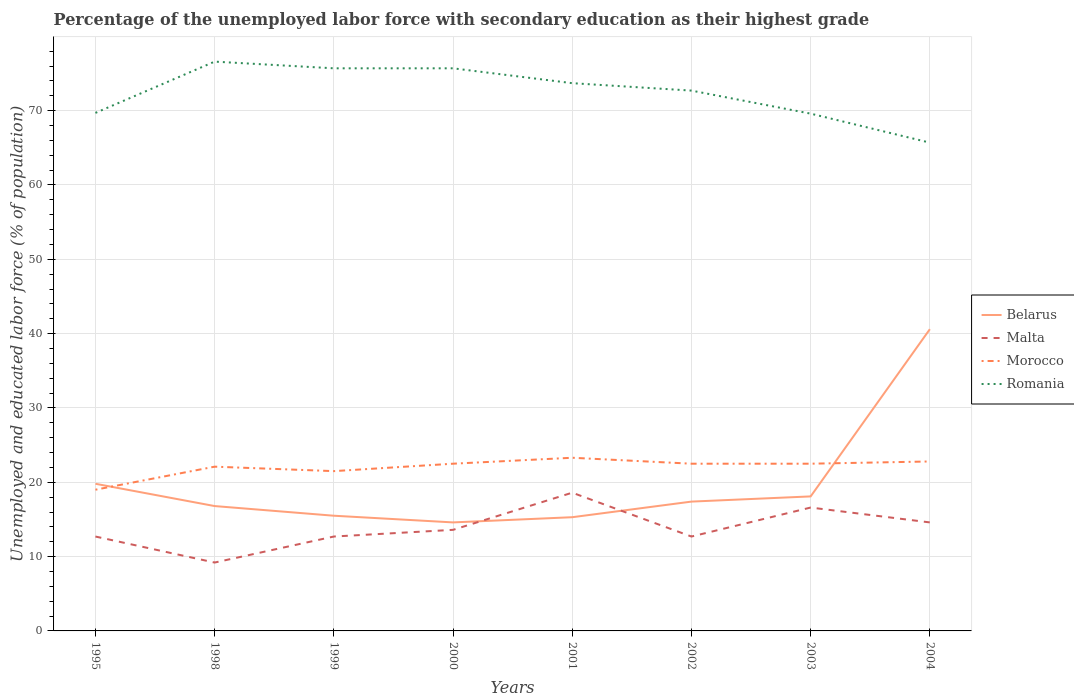Does the line corresponding to Romania intersect with the line corresponding to Morocco?
Your answer should be compact. No. Is the number of lines equal to the number of legend labels?
Your answer should be very brief. Yes. Across all years, what is the maximum percentage of the unemployed labor force with secondary education in Morocco?
Keep it short and to the point. 19. In which year was the percentage of the unemployed labor force with secondary education in Morocco maximum?
Provide a succinct answer. 1995. What is the total percentage of the unemployed labor force with secondary education in Romania in the graph?
Offer a terse response. 3.9. What is the difference between the highest and the second highest percentage of the unemployed labor force with secondary education in Malta?
Ensure brevity in your answer.  9.4. How many lines are there?
Your answer should be very brief. 4. How many years are there in the graph?
Offer a terse response. 8. What is the difference between two consecutive major ticks on the Y-axis?
Your answer should be compact. 10. What is the title of the graph?
Provide a short and direct response. Percentage of the unemployed labor force with secondary education as their highest grade. Does "Slovak Republic" appear as one of the legend labels in the graph?
Ensure brevity in your answer.  No. What is the label or title of the X-axis?
Make the answer very short. Years. What is the label or title of the Y-axis?
Make the answer very short. Unemployed and educated labor force (% of population). What is the Unemployed and educated labor force (% of population) of Belarus in 1995?
Your response must be concise. 19.8. What is the Unemployed and educated labor force (% of population) of Malta in 1995?
Give a very brief answer. 12.7. What is the Unemployed and educated labor force (% of population) in Romania in 1995?
Offer a very short reply. 69.7. What is the Unemployed and educated labor force (% of population) in Belarus in 1998?
Ensure brevity in your answer.  16.8. What is the Unemployed and educated labor force (% of population) of Malta in 1998?
Your answer should be compact. 9.2. What is the Unemployed and educated labor force (% of population) in Morocco in 1998?
Make the answer very short. 22.1. What is the Unemployed and educated labor force (% of population) of Romania in 1998?
Your answer should be very brief. 76.6. What is the Unemployed and educated labor force (% of population) in Malta in 1999?
Your answer should be very brief. 12.7. What is the Unemployed and educated labor force (% of population) in Morocco in 1999?
Your answer should be compact. 21.5. What is the Unemployed and educated labor force (% of population) of Romania in 1999?
Give a very brief answer. 75.7. What is the Unemployed and educated labor force (% of population) of Belarus in 2000?
Your answer should be very brief. 14.6. What is the Unemployed and educated labor force (% of population) of Malta in 2000?
Provide a short and direct response. 13.6. What is the Unemployed and educated labor force (% of population) in Romania in 2000?
Give a very brief answer. 75.7. What is the Unemployed and educated labor force (% of population) of Belarus in 2001?
Offer a very short reply. 15.3. What is the Unemployed and educated labor force (% of population) in Malta in 2001?
Offer a terse response. 18.6. What is the Unemployed and educated labor force (% of population) of Morocco in 2001?
Give a very brief answer. 23.3. What is the Unemployed and educated labor force (% of population) in Romania in 2001?
Your answer should be very brief. 73.7. What is the Unemployed and educated labor force (% of population) in Belarus in 2002?
Provide a short and direct response. 17.4. What is the Unemployed and educated labor force (% of population) of Malta in 2002?
Your response must be concise. 12.7. What is the Unemployed and educated labor force (% of population) in Romania in 2002?
Offer a very short reply. 72.7. What is the Unemployed and educated labor force (% of population) in Belarus in 2003?
Offer a very short reply. 18.1. What is the Unemployed and educated labor force (% of population) in Malta in 2003?
Provide a short and direct response. 16.6. What is the Unemployed and educated labor force (% of population) in Morocco in 2003?
Provide a succinct answer. 22.5. What is the Unemployed and educated labor force (% of population) in Romania in 2003?
Your answer should be compact. 69.6. What is the Unemployed and educated labor force (% of population) of Belarus in 2004?
Make the answer very short. 40.6. What is the Unemployed and educated labor force (% of population) in Malta in 2004?
Provide a succinct answer. 14.6. What is the Unemployed and educated labor force (% of population) in Morocco in 2004?
Your answer should be compact. 22.8. What is the Unemployed and educated labor force (% of population) in Romania in 2004?
Offer a terse response. 65.7. Across all years, what is the maximum Unemployed and educated labor force (% of population) in Belarus?
Give a very brief answer. 40.6. Across all years, what is the maximum Unemployed and educated labor force (% of population) of Malta?
Give a very brief answer. 18.6. Across all years, what is the maximum Unemployed and educated labor force (% of population) of Morocco?
Your answer should be compact. 23.3. Across all years, what is the maximum Unemployed and educated labor force (% of population) of Romania?
Ensure brevity in your answer.  76.6. Across all years, what is the minimum Unemployed and educated labor force (% of population) of Belarus?
Provide a short and direct response. 14.6. Across all years, what is the minimum Unemployed and educated labor force (% of population) in Malta?
Give a very brief answer. 9.2. Across all years, what is the minimum Unemployed and educated labor force (% of population) in Romania?
Provide a short and direct response. 65.7. What is the total Unemployed and educated labor force (% of population) in Belarus in the graph?
Your answer should be very brief. 158.1. What is the total Unemployed and educated labor force (% of population) in Malta in the graph?
Your response must be concise. 110.7. What is the total Unemployed and educated labor force (% of population) in Morocco in the graph?
Your response must be concise. 176.2. What is the total Unemployed and educated labor force (% of population) of Romania in the graph?
Give a very brief answer. 579.4. What is the difference between the Unemployed and educated labor force (% of population) in Belarus in 1995 and that in 1998?
Your response must be concise. 3. What is the difference between the Unemployed and educated labor force (% of population) in Malta in 1995 and that in 1998?
Your response must be concise. 3.5. What is the difference between the Unemployed and educated labor force (% of population) of Morocco in 1995 and that in 1998?
Keep it short and to the point. -3.1. What is the difference between the Unemployed and educated labor force (% of population) of Romania in 1995 and that in 1998?
Give a very brief answer. -6.9. What is the difference between the Unemployed and educated labor force (% of population) of Morocco in 1995 and that in 1999?
Offer a very short reply. -2.5. What is the difference between the Unemployed and educated labor force (% of population) in Romania in 1995 and that in 1999?
Provide a succinct answer. -6. What is the difference between the Unemployed and educated labor force (% of population) of Malta in 1995 and that in 2000?
Provide a succinct answer. -0.9. What is the difference between the Unemployed and educated labor force (% of population) in Belarus in 1995 and that in 2001?
Your response must be concise. 4.5. What is the difference between the Unemployed and educated labor force (% of population) in Malta in 1995 and that in 2001?
Your answer should be compact. -5.9. What is the difference between the Unemployed and educated labor force (% of population) in Romania in 1995 and that in 2001?
Offer a terse response. -4. What is the difference between the Unemployed and educated labor force (% of population) of Belarus in 1995 and that in 2002?
Keep it short and to the point. 2.4. What is the difference between the Unemployed and educated labor force (% of population) in Morocco in 1995 and that in 2002?
Ensure brevity in your answer.  -3.5. What is the difference between the Unemployed and educated labor force (% of population) of Belarus in 1995 and that in 2003?
Ensure brevity in your answer.  1.7. What is the difference between the Unemployed and educated labor force (% of population) in Romania in 1995 and that in 2003?
Your answer should be very brief. 0.1. What is the difference between the Unemployed and educated labor force (% of population) of Belarus in 1995 and that in 2004?
Your response must be concise. -20.8. What is the difference between the Unemployed and educated labor force (% of population) in Morocco in 1995 and that in 2004?
Keep it short and to the point. -3.8. What is the difference between the Unemployed and educated labor force (% of population) of Romania in 1995 and that in 2004?
Your answer should be very brief. 4. What is the difference between the Unemployed and educated labor force (% of population) of Belarus in 1998 and that in 1999?
Give a very brief answer. 1.3. What is the difference between the Unemployed and educated labor force (% of population) in Morocco in 1998 and that in 1999?
Your answer should be very brief. 0.6. What is the difference between the Unemployed and educated labor force (% of population) of Romania in 1998 and that in 2000?
Provide a short and direct response. 0.9. What is the difference between the Unemployed and educated labor force (% of population) in Belarus in 1998 and that in 2001?
Provide a short and direct response. 1.5. What is the difference between the Unemployed and educated labor force (% of population) in Belarus in 1998 and that in 2002?
Provide a succinct answer. -0.6. What is the difference between the Unemployed and educated labor force (% of population) of Malta in 1998 and that in 2002?
Keep it short and to the point. -3.5. What is the difference between the Unemployed and educated labor force (% of population) in Morocco in 1998 and that in 2002?
Ensure brevity in your answer.  -0.4. What is the difference between the Unemployed and educated labor force (% of population) of Romania in 1998 and that in 2002?
Your answer should be very brief. 3.9. What is the difference between the Unemployed and educated labor force (% of population) in Belarus in 1998 and that in 2003?
Offer a very short reply. -1.3. What is the difference between the Unemployed and educated labor force (% of population) in Morocco in 1998 and that in 2003?
Offer a very short reply. -0.4. What is the difference between the Unemployed and educated labor force (% of population) of Belarus in 1998 and that in 2004?
Your response must be concise. -23.8. What is the difference between the Unemployed and educated labor force (% of population) in Belarus in 1999 and that in 2000?
Give a very brief answer. 0.9. What is the difference between the Unemployed and educated labor force (% of population) in Romania in 1999 and that in 2001?
Provide a short and direct response. 2. What is the difference between the Unemployed and educated labor force (% of population) of Morocco in 1999 and that in 2002?
Give a very brief answer. -1. What is the difference between the Unemployed and educated labor force (% of population) in Romania in 1999 and that in 2002?
Your response must be concise. 3. What is the difference between the Unemployed and educated labor force (% of population) of Belarus in 1999 and that in 2003?
Provide a short and direct response. -2.6. What is the difference between the Unemployed and educated labor force (% of population) of Belarus in 1999 and that in 2004?
Make the answer very short. -25.1. What is the difference between the Unemployed and educated labor force (% of population) in Malta in 1999 and that in 2004?
Your answer should be very brief. -1.9. What is the difference between the Unemployed and educated labor force (% of population) of Morocco in 1999 and that in 2004?
Make the answer very short. -1.3. What is the difference between the Unemployed and educated labor force (% of population) of Belarus in 2000 and that in 2001?
Make the answer very short. -0.7. What is the difference between the Unemployed and educated labor force (% of population) in Malta in 2000 and that in 2001?
Give a very brief answer. -5. What is the difference between the Unemployed and educated labor force (% of population) of Morocco in 2000 and that in 2002?
Offer a terse response. 0. What is the difference between the Unemployed and educated labor force (% of population) of Malta in 2000 and that in 2003?
Provide a short and direct response. -3. What is the difference between the Unemployed and educated labor force (% of population) of Romania in 2000 and that in 2003?
Provide a succinct answer. 6.1. What is the difference between the Unemployed and educated labor force (% of population) in Belarus in 2001 and that in 2002?
Provide a succinct answer. -2.1. What is the difference between the Unemployed and educated labor force (% of population) in Malta in 2001 and that in 2002?
Provide a succinct answer. 5.9. What is the difference between the Unemployed and educated labor force (% of population) in Morocco in 2001 and that in 2002?
Make the answer very short. 0.8. What is the difference between the Unemployed and educated labor force (% of population) in Romania in 2001 and that in 2002?
Provide a succinct answer. 1. What is the difference between the Unemployed and educated labor force (% of population) in Belarus in 2001 and that in 2003?
Offer a terse response. -2.8. What is the difference between the Unemployed and educated labor force (% of population) of Morocco in 2001 and that in 2003?
Make the answer very short. 0.8. What is the difference between the Unemployed and educated labor force (% of population) in Romania in 2001 and that in 2003?
Ensure brevity in your answer.  4.1. What is the difference between the Unemployed and educated labor force (% of population) in Belarus in 2001 and that in 2004?
Give a very brief answer. -25.3. What is the difference between the Unemployed and educated labor force (% of population) in Morocco in 2001 and that in 2004?
Provide a succinct answer. 0.5. What is the difference between the Unemployed and educated labor force (% of population) of Malta in 2002 and that in 2003?
Keep it short and to the point. -3.9. What is the difference between the Unemployed and educated labor force (% of population) of Morocco in 2002 and that in 2003?
Your answer should be very brief. 0. What is the difference between the Unemployed and educated labor force (% of population) of Romania in 2002 and that in 2003?
Keep it short and to the point. 3.1. What is the difference between the Unemployed and educated labor force (% of population) in Belarus in 2002 and that in 2004?
Provide a succinct answer. -23.2. What is the difference between the Unemployed and educated labor force (% of population) in Malta in 2002 and that in 2004?
Make the answer very short. -1.9. What is the difference between the Unemployed and educated labor force (% of population) of Romania in 2002 and that in 2004?
Ensure brevity in your answer.  7. What is the difference between the Unemployed and educated labor force (% of population) of Belarus in 2003 and that in 2004?
Your answer should be compact. -22.5. What is the difference between the Unemployed and educated labor force (% of population) of Malta in 2003 and that in 2004?
Keep it short and to the point. 2. What is the difference between the Unemployed and educated labor force (% of population) of Morocco in 2003 and that in 2004?
Your answer should be compact. -0.3. What is the difference between the Unemployed and educated labor force (% of population) of Romania in 2003 and that in 2004?
Give a very brief answer. 3.9. What is the difference between the Unemployed and educated labor force (% of population) of Belarus in 1995 and the Unemployed and educated labor force (% of population) of Romania in 1998?
Provide a succinct answer. -56.8. What is the difference between the Unemployed and educated labor force (% of population) of Malta in 1995 and the Unemployed and educated labor force (% of population) of Morocco in 1998?
Give a very brief answer. -9.4. What is the difference between the Unemployed and educated labor force (% of population) of Malta in 1995 and the Unemployed and educated labor force (% of population) of Romania in 1998?
Keep it short and to the point. -63.9. What is the difference between the Unemployed and educated labor force (% of population) in Morocco in 1995 and the Unemployed and educated labor force (% of population) in Romania in 1998?
Keep it short and to the point. -57.6. What is the difference between the Unemployed and educated labor force (% of population) in Belarus in 1995 and the Unemployed and educated labor force (% of population) in Malta in 1999?
Keep it short and to the point. 7.1. What is the difference between the Unemployed and educated labor force (% of population) of Belarus in 1995 and the Unemployed and educated labor force (% of population) of Morocco in 1999?
Your answer should be compact. -1.7. What is the difference between the Unemployed and educated labor force (% of population) of Belarus in 1995 and the Unemployed and educated labor force (% of population) of Romania in 1999?
Keep it short and to the point. -55.9. What is the difference between the Unemployed and educated labor force (% of population) of Malta in 1995 and the Unemployed and educated labor force (% of population) of Morocco in 1999?
Your response must be concise. -8.8. What is the difference between the Unemployed and educated labor force (% of population) of Malta in 1995 and the Unemployed and educated labor force (% of population) of Romania in 1999?
Make the answer very short. -63. What is the difference between the Unemployed and educated labor force (% of population) of Morocco in 1995 and the Unemployed and educated labor force (% of population) of Romania in 1999?
Your answer should be compact. -56.7. What is the difference between the Unemployed and educated labor force (% of population) in Belarus in 1995 and the Unemployed and educated labor force (% of population) in Romania in 2000?
Ensure brevity in your answer.  -55.9. What is the difference between the Unemployed and educated labor force (% of population) of Malta in 1995 and the Unemployed and educated labor force (% of population) of Romania in 2000?
Offer a very short reply. -63. What is the difference between the Unemployed and educated labor force (% of population) of Morocco in 1995 and the Unemployed and educated labor force (% of population) of Romania in 2000?
Ensure brevity in your answer.  -56.7. What is the difference between the Unemployed and educated labor force (% of population) in Belarus in 1995 and the Unemployed and educated labor force (% of population) in Malta in 2001?
Offer a very short reply. 1.2. What is the difference between the Unemployed and educated labor force (% of population) of Belarus in 1995 and the Unemployed and educated labor force (% of population) of Romania in 2001?
Ensure brevity in your answer.  -53.9. What is the difference between the Unemployed and educated labor force (% of population) of Malta in 1995 and the Unemployed and educated labor force (% of population) of Romania in 2001?
Keep it short and to the point. -61. What is the difference between the Unemployed and educated labor force (% of population) in Morocco in 1995 and the Unemployed and educated labor force (% of population) in Romania in 2001?
Offer a very short reply. -54.7. What is the difference between the Unemployed and educated labor force (% of population) in Belarus in 1995 and the Unemployed and educated labor force (% of population) in Morocco in 2002?
Your answer should be compact. -2.7. What is the difference between the Unemployed and educated labor force (% of population) of Belarus in 1995 and the Unemployed and educated labor force (% of population) of Romania in 2002?
Ensure brevity in your answer.  -52.9. What is the difference between the Unemployed and educated labor force (% of population) in Malta in 1995 and the Unemployed and educated labor force (% of population) in Romania in 2002?
Your response must be concise. -60. What is the difference between the Unemployed and educated labor force (% of population) of Morocco in 1995 and the Unemployed and educated labor force (% of population) of Romania in 2002?
Give a very brief answer. -53.7. What is the difference between the Unemployed and educated labor force (% of population) in Belarus in 1995 and the Unemployed and educated labor force (% of population) in Malta in 2003?
Keep it short and to the point. 3.2. What is the difference between the Unemployed and educated labor force (% of population) of Belarus in 1995 and the Unemployed and educated labor force (% of population) of Romania in 2003?
Give a very brief answer. -49.8. What is the difference between the Unemployed and educated labor force (% of population) of Malta in 1995 and the Unemployed and educated labor force (% of population) of Morocco in 2003?
Keep it short and to the point. -9.8. What is the difference between the Unemployed and educated labor force (% of population) of Malta in 1995 and the Unemployed and educated labor force (% of population) of Romania in 2003?
Your answer should be very brief. -56.9. What is the difference between the Unemployed and educated labor force (% of population) of Morocco in 1995 and the Unemployed and educated labor force (% of population) of Romania in 2003?
Ensure brevity in your answer.  -50.6. What is the difference between the Unemployed and educated labor force (% of population) in Belarus in 1995 and the Unemployed and educated labor force (% of population) in Morocco in 2004?
Offer a very short reply. -3. What is the difference between the Unemployed and educated labor force (% of population) of Belarus in 1995 and the Unemployed and educated labor force (% of population) of Romania in 2004?
Offer a very short reply. -45.9. What is the difference between the Unemployed and educated labor force (% of population) of Malta in 1995 and the Unemployed and educated labor force (% of population) of Romania in 2004?
Give a very brief answer. -53. What is the difference between the Unemployed and educated labor force (% of population) in Morocco in 1995 and the Unemployed and educated labor force (% of population) in Romania in 2004?
Keep it short and to the point. -46.7. What is the difference between the Unemployed and educated labor force (% of population) of Belarus in 1998 and the Unemployed and educated labor force (% of population) of Malta in 1999?
Your answer should be compact. 4.1. What is the difference between the Unemployed and educated labor force (% of population) of Belarus in 1998 and the Unemployed and educated labor force (% of population) of Morocco in 1999?
Make the answer very short. -4.7. What is the difference between the Unemployed and educated labor force (% of population) of Belarus in 1998 and the Unemployed and educated labor force (% of population) of Romania in 1999?
Keep it short and to the point. -58.9. What is the difference between the Unemployed and educated labor force (% of population) of Malta in 1998 and the Unemployed and educated labor force (% of population) of Romania in 1999?
Your response must be concise. -66.5. What is the difference between the Unemployed and educated labor force (% of population) in Morocco in 1998 and the Unemployed and educated labor force (% of population) in Romania in 1999?
Provide a short and direct response. -53.6. What is the difference between the Unemployed and educated labor force (% of population) in Belarus in 1998 and the Unemployed and educated labor force (% of population) in Malta in 2000?
Your response must be concise. 3.2. What is the difference between the Unemployed and educated labor force (% of population) in Belarus in 1998 and the Unemployed and educated labor force (% of population) in Romania in 2000?
Keep it short and to the point. -58.9. What is the difference between the Unemployed and educated labor force (% of population) of Malta in 1998 and the Unemployed and educated labor force (% of population) of Morocco in 2000?
Give a very brief answer. -13.3. What is the difference between the Unemployed and educated labor force (% of population) of Malta in 1998 and the Unemployed and educated labor force (% of population) of Romania in 2000?
Ensure brevity in your answer.  -66.5. What is the difference between the Unemployed and educated labor force (% of population) in Morocco in 1998 and the Unemployed and educated labor force (% of population) in Romania in 2000?
Ensure brevity in your answer.  -53.6. What is the difference between the Unemployed and educated labor force (% of population) of Belarus in 1998 and the Unemployed and educated labor force (% of population) of Romania in 2001?
Provide a succinct answer. -56.9. What is the difference between the Unemployed and educated labor force (% of population) in Malta in 1998 and the Unemployed and educated labor force (% of population) in Morocco in 2001?
Keep it short and to the point. -14.1. What is the difference between the Unemployed and educated labor force (% of population) of Malta in 1998 and the Unemployed and educated labor force (% of population) of Romania in 2001?
Your answer should be compact. -64.5. What is the difference between the Unemployed and educated labor force (% of population) of Morocco in 1998 and the Unemployed and educated labor force (% of population) of Romania in 2001?
Make the answer very short. -51.6. What is the difference between the Unemployed and educated labor force (% of population) of Belarus in 1998 and the Unemployed and educated labor force (% of population) of Malta in 2002?
Provide a short and direct response. 4.1. What is the difference between the Unemployed and educated labor force (% of population) of Belarus in 1998 and the Unemployed and educated labor force (% of population) of Morocco in 2002?
Your answer should be very brief. -5.7. What is the difference between the Unemployed and educated labor force (% of population) in Belarus in 1998 and the Unemployed and educated labor force (% of population) in Romania in 2002?
Ensure brevity in your answer.  -55.9. What is the difference between the Unemployed and educated labor force (% of population) in Malta in 1998 and the Unemployed and educated labor force (% of population) in Romania in 2002?
Offer a very short reply. -63.5. What is the difference between the Unemployed and educated labor force (% of population) of Morocco in 1998 and the Unemployed and educated labor force (% of population) of Romania in 2002?
Your answer should be very brief. -50.6. What is the difference between the Unemployed and educated labor force (% of population) in Belarus in 1998 and the Unemployed and educated labor force (% of population) in Morocco in 2003?
Give a very brief answer. -5.7. What is the difference between the Unemployed and educated labor force (% of population) of Belarus in 1998 and the Unemployed and educated labor force (% of population) of Romania in 2003?
Provide a short and direct response. -52.8. What is the difference between the Unemployed and educated labor force (% of population) in Malta in 1998 and the Unemployed and educated labor force (% of population) in Morocco in 2003?
Provide a succinct answer. -13.3. What is the difference between the Unemployed and educated labor force (% of population) of Malta in 1998 and the Unemployed and educated labor force (% of population) of Romania in 2003?
Keep it short and to the point. -60.4. What is the difference between the Unemployed and educated labor force (% of population) in Morocco in 1998 and the Unemployed and educated labor force (% of population) in Romania in 2003?
Provide a succinct answer. -47.5. What is the difference between the Unemployed and educated labor force (% of population) in Belarus in 1998 and the Unemployed and educated labor force (% of population) in Malta in 2004?
Give a very brief answer. 2.2. What is the difference between the Unemployed and educated labor force (% of population) of Belarus in 1998 and the Unemployed and educated labor force (% of population) of Romania in 2004?
Your response must be concise. -48.9. What is the difference between the Unemployed and educated labor force (% of population) in Malta in 1998 and the Unemployed and educated labor force (% of population) in Romania in 2004?
Provide a short and direct response. -56.5. What is the difference between the Unemployed and educated labor force (% of population) in Morocco in 1998 and the Unemployed and educated labor force (% of population) in Romania in 2004?
Give a very brief answer. -43.6. What is the difference between the Unemployed and educated labor force (% of population) in Belarus in 1999 and the Unemployed and educated labor force (% of population) in Morocco in 2000?
Offer a terse response. -7. What is the difference between the Unemployed and educated labor force (% of population) of Belarus in 1999 and the Unemployed and educated labor force (% of population) of Romania in 2000?
Your answer should be very brief. -60.2. What is the difference between the Unemployed and educated labor force (% of population) of Malta in 1999 and the Unemployed and educated labor force (% of population) of Romania in 2000?
Ensure brevity in your answer.  -63. What is the difference between the Unemployed and educated labor force (% of population) of Morocco in 1999 and the Unemployed and educated labor force (% of population) of Romania in 2000?
Offer a very short reply. -54.2. What is the difference between the Unemployed and educated labor force (% of population) in Belarus in 1999 and the Unemployed and educated labor force (% of population) in Malta in 2001?
Your answer should be compact. -3.1. What is the difference between the Unemployed and educated labor force (% of population) in Belarus in 1999 and the Unemployed and educated labor force (% of population) in Romania in 2001?
Provide a succinct answer. -58.2. What is the difference between the Unemployed and educated labor force (% of population) in Malta in 1999 and the Unemployed and educated labor force (% of population) in Morocco in 2001?
Your response must be concise. -10.6. What is the difference between the Unemployed and educated labor force (% of population) of Malta in 1999 and the Unemployed and educated labor force (% of population) of Romania in 2001?
Provide a succinct answer. -61. What is the difference between the Unemployed and educated labor force (% of population) in Morocco in 1999 and the Unemployed and educated labor force (% of population) in Romania in 2001?
Provide a short and direct response. -52.2. What is the difference between the Unemployed and educated labor force (% of population) of Belarus in 1999 and the Unemployed and educated labor force (% of population) of Romania in 2002?
Your answer should be compact. -57.2. What is the difference between the Unemployed and educated labor force (% of population) of Malta in 1999 and the Unemployed and educated labor force (% of population) of Morocco in 2002?
Keep it short and to the point. -9.8. What is the difference between the Unemployed and educated labor force (% of population) in Malta in 1999 and the Unemployed and educated labor force (% of population) in Romania in 2002?
Provide a succinct answer. -60. What is the difference between the Unemployed and educated labor force (% of population) in Morocco in 1999 and the Unemployed and educated labor force (% of population) in Romania in 2002?
Ensure brevity in your answer.  -51.2. What is the difference between the Unemployed and educated labor force (% of population) in Belarus in 1999 and the Unemployed and educated labor force (% of population) in Romania in 2003?
Offer a terse response. -54.1. What is the difference between the Unemployed and educated labor force (% of population) in Malta in 1999 and the Unemployed and educated labor force (% of population) in Morocco in 2003?
Offer a very short reply. -9.8. What is the difference between the Unemployed and educated labor force (% of population) of Malta in 1999 and the Unemployed and educated labor force (% of population) of Romania in 2003?
Offer a terse response. -56.9. What is the difference between the Unemployed and educated labor force (% of population) in Morocco in 1999 and the Unemployed and educated labor force (% of population) in Romania in 2003?
Offer a very short reply. -48.1. What is the difference between the Unemployed and educated labor force (% of population) of Belarus in 1999 and the Unemployed and educated labor force (% of population) of Romania in 2004?
Your answer should be very brief. -50.2. What is the difference between the Unemployed and educated labor force (% of population) of Malta in 1999 and the Unemployed and educated labor force (% of population) of Romania in 2004?
Your response must be concise. -53. What is the difference between the Unemployed and educated labor force (% of population) in Morocco in 1999 and the Unemployed and educated labor force (% of population) in Romania in 2004?
Make the answer very short. -44.2. What is the difference between the Unemployed and educated labor force (% of population) of Belarus in 2000 and the Unemployed and educated labor force (% of population) of Malta in 2001?
Make the answer very short. -4. What is the difference between the Unemployed and educated labor force (% of population) of Belarus in 2000 and the Unemployed and educated labor force (% of population) of Romania in 2001?
Your response must be concise. -59.1. What is the difference between the Unemployed and educated labor force (% of population) of Malta in 2000 and the Unemployed and educated labor force (% of population) of Romania in 2001?
Provide a short and direct response. -60.1. What is the difference between the Unemployed and educated labor force (% of population) in Morocco in 2000 and the Unemployed and educated labor force (% of population) in Romania in 2001?
Keep it short and to the point. -51.2. What is the difference between the Unemployed and educated labor force (% of population) in Belarus in 2000 and the Unemployed and educated labor force (% of population) in Malta in 2002?
Your response must be concise. 1.9. What is the difference between the Unemployed and educated labor force (% of population) of Belarus in 2000 and the Unemployed and educated labor force (% of population) of Morocco in 2002?
Your response must be concise. -7.9. What is the difference between the Unemployed and educated labor force (% of population) of Belarus in 2000 and the Unemployed and educated labor force (% of population) of Romania in 2002?
Offer a very short reply. -58.1. What is the difference between the Unemployed and educated labor force (% of population) of Malta in 2000 and the Unemployed and educated labor force (% of population) of Romania in 2002?
Offer a very short reply. -59.1. What is the difference between the Unemployed and educated labor force (% of population) of Morocco in 2000 and the Unemployed and educated labor force (% of population) of Romania in 2002?
Provide a succinct answer. -50.2. What is the difference between the Unemployed and educated labor force (% of population) in Belarus in 2000 and the Unemployed and educated labor force (% of population) in Malta in 2003?
Ensure brevity in your answer.  -2. What is the difference between the Unemployed and educated labor force (% of population) in Belarus in 2000 and the Unemployed and educated labor force (% of population) in Romania in 2003?
Keep it short and to the point. -55. What is the difference between the Unemployed and educated labor force (% of population) of Malta in 2000 and the Unemployed and educated labor force (% of population) of Morocco in 2003?
Ensure brevity in your answer.  -8.9. What is the difference between the Unemployed and educated labor force (% of population) of Malta in 2000 and the Unemployed and educated labor force (% of population) of Romania in 2003?
Provide a succinct answer. -56. What is the difference between the Unemployed and educated labor force (% of population) of Morocco in 2000 and the Unemployed and educated labor force (% of population) of Romania in 2003?
Offer a terse response. -47.1. What is the difference between the Unemployed and educated labor force (% of population) of Belarus in 2000 and the Unemployed and educated labor force (% of population) of Malta in 2004?
Provide a short and direct response. 0. What is the difference between the Unemployed and educated labor force (% of population) in Belarus in 2000 and the Unemployed and educated labor force (% of population) in Romania in 2004?
Offer a very short reply. -51.1. What is the difference between the Unemployed and educated labor force (% of population) in Malta in 2000 and the Unemployed and educated labor force (% of population) in Morocco in 2004?
Your answer should be compact. -9.2. What is the difference between the Unemployed and educated labor force (% of population) in Malta in 2000 and the Unemployed and educated labor force (% of population) in Romania in 2004?
Provide a short and direct response. -52.1. What is the difference between the Unemployed and educated labor force (% of population) of Morocco in 2000 and the Unemployed and educated labor force (% of population) of Romania in 2004?
Ensure brevity in your answer.  -43.2. What is the difference between the Unemployed and educated labor force (% of population) of Belarus in 2001 and the Unemployed and educated labor force (% of population) of Morocco in 2002?
Your answer should be very brief. -7.2. What is the difference between the Unemployed and educated labor force (% of population) in Belarus in 2001 and the Unemployed and educated labor force (% of population) in Romania in 2002?
Offer a very short reply. -57.4. What is the difference between the Unemployed and educated labor force (% of population) of Malta in 2001 and the Unemployed and educated labor force (% of population) of Romania in 2002?
Give a very brief answer. -54.1. What is the difference between the Unemployed and educated labor force (% of population) of Morocco in 2001 and the Unemployed and educated labor force (% of population) of Romania in 2002?
Offer a very short reply. -49.4. What is the difference between the Unemployed and educated labor force (% of population) in Belarus in 2001 and the Unemployed and educated labor force (% of population) in Romania in 2003?
Provide a short and direct response. -54.3. What is the difference between the Unemployed and educated labor force (% of population) in Malta in 2001 and the Unemployed and educated labor force (% of population) in Romania in 2003?
Keep it short and to the point. -51. What is the difference between the Unemployed and educated labor force (% of population) in Morocco in 2001 and the Unemployed and educated labor force (% of population) in Romania in 2003?
Your answer should be compact. -46.3. What is the difference between the Unemployed and educated labor force (% of population) of Belarus in 2001 and the Unemployed and educated labor force (% of population) of Malta in 2004?
Your answer should be very brief. 0.7. What is the difference between the Unemployed and educated labor force (% of population) of Belarus in 2001 and the Unemployed and educated labor force (% of population) of Morocco in 2004?
Ensure brevity in your answer.  -7.5. What is the difference between the Unemployed and educated labor force (% of population) in Belarus in 2001 and the Unemployed and educated labor force (% of population) in Romania in 2004?
Your response must be concise. -50.4. What is the difference between the Unemployed and educated labor force (% of population) of Malta in 2001 and the Unemployed and educated labor force (% of population) of Morocco in 2004?
Provide a short and direct response. -4.2. What is the difference between the Unemployed and educated labor force (% of population) of Malta in 2001 and the Unemployed and educated labor force (% of population) of Romania in 2004?
Make the answer very short. -47.1. What is the difference between the Unemployed and educated labor force (% of population) of Morocco in 2001 and the Unemployed and educated labor force (% of population) of Romania in 2004?
Keep it short and to the point. -42.4. What is the difference between the Unemployed and educated labor force (% of population) in Belarus in 2002 and the Unemployed and educated labor force (% of population) in Morocco in 2003?
Ensure brevity in your answer.  -5.1. What is the difference between the Unemployed and educated labor force (% of population) in Belarus in 2002 and the Unemployed and educated labor force (% of population) in Romania in 2003?
Ensure brevity in your answer.  -52.2. What is the difference between the Unemployed and educated labor force (% of population) in Malta in 2002 and the Unemployed and educated labor force (% of population) in Romania in 2003?
Provide a succinct answer. -56.9. What is the difference between the Unemployed and educated labor force (% of population) in Morocco in 2002 and the Unemployed and educated labor force (% of population) in Romania in 2003?
Offer a terse response. -47.1. What is the difference between the Unemployed and educated labor force (% of population) in Belarus in 2002 and the Unemployed and educated labor force (% of population) in Malta in 2004?
Keep it short and to the point. 2.8. What is the difference between the Unemployed and educated labor force (% of population) in Belarus in 2002 and the Unemployed and educated labor force (% of population) in Romania in 2004?
Make the answer very short. -48.3. What is the difference between the Unemployed and educated labor force (% of population) in Malta in 2002 and the Unemployed and educated labor force (% of population) in Romania in 2004?
Ensure brevity in your answer.  -53. What is the difference between the Unemployed and educated labor force (% of population) of Morocco in 2002 and the Unemployed and educated labor force (% of population) of Romania in 2004?
Provide a short and direct response. -43.2. What is the difference between the Unemployed and educated labor force (% of population) of Belarus in 2003 and the Unemployed and educated labor force (% of population) of Morocco in 2004?
Give a very brief answer. -4.7. What is the difference between the Unemployed and educated labor force (% of population) of Belarus in 2003 and the Unemployed and educated labor force (% of population) of Romania in 2004?
Your answer should be very brief. -47.6. What is the difference between the Unemployed and educated labor force (% of population) in Malta in 2003 and the Unemployed and educated labor force (% of population) in Romania in 2004?
Your answer should be very brief. -49.1. What is the difference between the Unemployed and educated labor force (% of population) of Morocco in 2003 and the Unemployed and educated labor force (% of population) of Romania in 2004?
Your answer should be compact. -43.2. What is the average Unemployed and educated labor force (% of population) of Belarus per year?
Your answer should be compact. 19.76. What is the average Unemployed and educated labor force (% of population) of Malta per year?
Ensure brevity in your answer.  13.84. What is the average Unemployed and educated labor force (% of population) of Morocco per year?
Provide a short and direct response. 22.02. What is the average Unemployed and educated labor force (% of population) of Romania per year?
Your response must be concise. 72.42. In the year 1995, what is the difference between the Unemployed and educated labor force (% of population) of Belarus and Unemployed and educated labor force (% of population) of Malta?
Ensure brevity in your answer.  7.1. In the year 1995, what is the difference between the Unemployed and educated labor force (% of population) of Belarus and Unemployed and educated labor force (% of population) of Morocco?
Make the answer very short. 0.8. In the year 1995, what is the difference between the Unemployed and educated labor force (% of population) of Belarus and Unemployed and educated labor force (% of population) of Romania?
Provide a short and direct response. -49.9. In the year 1995, what is the difference between the Unemployed and educated labor force (% of population) of Malta and Unemployed and educated labor force (% of population) of Morocco?
Your answer should be very brief. -6.3. In the year 1995, what is the difference between the Unemployed and educated labor force (% of population) in Malta and Unemployed and educated labor force (% of population) in Romania?
Offer a very short reply. -57. In the year 1995, what is the difference between the Unemployed and educated labor force (% of population) in Morocco and Unemployed and educated labor force (% of population) in Romania?
Keep it short and to the point. -50.7. In the year 1998, what is the difference between the Unemployed and educated labor force (% of population) of Belarus and Unemployed and educated labor force (% of population) of Malta?
Offer a terse response. 7.6. In the year 1998, what is the difference between the Unemployed and educated labor force (% of population) of Belarus and Unemployed and educated labor force (% of population) of Romania?
Offer a terse response. -59.8. In the year 1998, what is the difference between the Unemployed and educated labor force (% of population) of Malta and Unemployed and educated labor force (% of population) of Morocco?
Your response must be concise. -12.9. In the year 1998, what is the difference between the Unemployed and educated labor force (% of population) of Malta and Unemployed and educated labor force (% of population) of Romania?
Keep it short and to the point. -67.4. In the year 1998, what is the difference between the Unemployed and educated labor force (% of population) in Morocco and Unemployed and educated labor force (% of population) in Romania?
Offer a terse response. -54.5. In the year 1999, what is the difference between the Unemployed and educated labor force (% of population) of Belarus and Unemployed and educated labor force (% of population) of Romania?
Offer a very short reply. -60.2. In the year 1999, what is the difference between the Unemployed and educated labor force (% of population) of Malta and Unemployed and educated labor force (% of population) of Morocco?
Your answer should be very brief. -8.8. In the year 1999, what is the difference between the Unemployed and educated labor force (% of population) in Malta and Unemployed and educated labor force (% of population) in Romania?
Your answer should be compact. -63. In the year 1999, what is the difference between the Unemployed and educated labor force (% of population) of Morocco and Unemployed and educated labor force (% of population) of Romania?
Your answer should be compact. -54.2. In the year 2000, what is the difference between the Unemployed and educated labor force (% of population) in Belarus and Unemployed and educated labor force (% of population) in Romania?
Keep it short and to the point. -61.1. In the year 2000, what is the difference between the Unemployed and educated labor force (% of population) of Malta and Unemployed and educated labor force (% of population) of Morocco?
Provide a short and direct response. -8.9. In the year 2000, what is the difference between the Unemployed and educated labor force (% of population) in Malta and Unemployed and educated labor force (% of population) in Romania?
Provide a short and direct response. -62.1. In the year 2000, what is the difference between the Unemployed and educated labor force (% of population) of Morocco and Unemployed and educated labor force (% of population) of Romania?
Your answer should be very brief. -53.2. In the year 2001, what is the difference between the Unemployed and educated labor force (% of population) in Belarus and Unemployed and educated labor force (% of population) in Morocco?
Offer a very short reply. -8. In the year 2001, what is the difference between the Unemployed and educated labor force (% of population) in Belarus and Unemployed and educated labor force (% of population) in Romania?
Provide a short and direct response. -58.4. In the year 2001, what is the difference between the Unemployed and educated labor force (% of population) of Malta and Unemployed and educated labor force (% of population) of Morocco?
Offer a very short reply. -4.7. In the year 2001, what is the difference between the Unemployed and educated labor force (% of population) in Malta and Unemployed and educated labor force (% of population) in Romania?
Offer a very short reply. -55.1. In the year 2001, what is the difference between the Unemployed and educated labor force (% of population) in Morocco and Unemployed and educated labor force (% of population) in Romania?
Your answer should be compact. -50.4. In the year 2002, what is the difference between the Unemployed and educated labor force (% of population) in Belarus and Unemployed and educated labor force (% of population) in Malta?
Offer a very short reply. 4.7. In the year 2002, what is the difference between the Unemployed and educated labor force (% of population) of Belarus and Unemployed and educated labor force (% of population) of Romania?
Provide a short and direct response. -55.3. In the year 2002, what is the difference between the Unemployed and educated labor force (% of population) of Malta and Unemployed and educated labor force (% of population) of Romania?
Ensure brevity in your answer.  -60. In the year 2002, what is the difference between the Unemployed and educated labor force (% of population) of Morocco and Unemployed and educated labor force (% of population) of Romania?
Provide a short and direct response. -50.2. In the year 2003, what is the difference between the Unemployed and educated labor force (% of population) of Belarus and Unemployed and educated labor force (% of population) of Malta?
Provide a short and direct response. 1.5. In the year 2003, what is the difference between the Unemployed and educated labor force (% of population) of Belarus and Unemployed and educated labor force (% of population) of Romania?
Your answer should be compact. -51.5. In the year 2003, what is the difference between the Unemployed and educated labor force (% of population) in Malta and Unemployed and educated labor force (% of population) in Morocco?
Your response must be concise. -5.9. In the year 2003, what is the difference between the Unemployed and educated labor force (% of population) in Malta and Unemployed and educated labor force (% of population) in Romania?
Provide a short and direct response. -53. In the year 2003, what is the difference between the Unemployed and educated labor force (% of population) of Morocco and Unemployed and educated labor force (% of population) of Romania?
Your answer should be very brief. -47.1. In the year 2004, what is the difference between the Unemployed and educated labor force (% of population) in Belarus and Unemployed and educated labor force (% of population) in Romania?
Offer a terse response. -25.1. In the year 2004, what is the difference between the Unemployed and educated labor force (% of population) of Malta and Unemployed and educated labor force (% of population) of Romania?
Offer a terse response. -51.1. In the year 2004, what is the difference between the Unemployed and educated labor force (% of population) of Morocco and Unemployed and educated labor force (% of population) of Romania?
Offer a terse response. -42.9. What is the ratio of the Unemployed and educated labor force (% of population) of Belarus in 1995 to that in 1998?
Your response must be concise. 1.18. What is the ratio of the Unemployed and educated labor force (% of population) of Malta in 1995 to that in 1998?
Your answer should be compact. 1.38. What is the ratio of the Unemployed and educated labor force (% of population) of Morocco in 1995 to that in 1998?
Provide a succinct answer. 0.86. What is the ratio of the Unemployed and educated labor force (% of population) of Romania in 1995 to that in 1998?
Keep it short and to the point. 0.91. What is the ratio of the Unemployed and educated labor force (% of population) in Belarus in 1995 to that in 1999?
Provide a succinct answer. 1.28. What is the ratio of the Unemployed and educated labor force (% of population) of Morocco in 1995 to that in 1999?
Keep it short and to the point. 0.88. What is the ratio of the Unemployed and educated labor force (% of population) in Romania in 1995 to that in 1999?
Make the answer very short. 0.92. What is the ratio of the Unemployed and educated labor force (% of population) in Belarus in 1995 to that in 2000?
Your response must be concise. 1.36. What is the ratio of the Unemployed and educated labor force (% of population) of Malta in 1995 to that in 2000?
Offer a terse response. 0.93. What is the ratio of the Unemployed and educated labor force (% of population) of Morocco in 1995 to that in 2000?
Your answer should be compact. 0.84. What is the ratio of the Unemployed and educated labor force (% of population) of Romania in 1995 to that in 2000?
Your answer should be compact. 0.92. What is the ratio of the Unemployed and educated labor force (% of population) of Belarus in 1995 to that in 2001?
Provide a succinct answer. 1.29. What is the ratio of the Unemployed and educated labor force (% of population) in Malta in 1995 to that in 2001?
Make the answer very short. 0.68. What is the ratio of the Unemployed and educated labor force (% of population) of Morocco in 1995 to that in 2001?
Provide a short and direct response. 0.82. What is the ratio of the Unemployed and educated labor force (% of population) in Romania in 1995 to that in 2001?
Give a very brief answer. 0.95. What is the ratio of the Unemployed and educated labor force (% of population) in Belarus in 1995 to that in 2002?
Offer a very short reply. 1.14. What is the ratio of the Unemployed and educated labor force (% of population) of Malta in 1995 to that in 2002?
Offer a very short reply. 1. What is the ratio of the Unemployed and educated labor force (% of population) in Morocco in 1995 to that in 2002?
Provide a short and direct response. 0.84. What is the ratio of the Unemployed and educated labor force (% of population) of Romania in 1995 to that in 2002?
Offer a terse response. 0.96. What is the ratio of the Unemployed and educated labor force (% of population) in Belarus in 1995 to that in 2003?
Provide a succinct answer. 1.09. What is the ratio of the Unemployed and educated labor force (% of population) in Malta in 1995 to that in 2003?
Offer a very short reply. 0.77. What is the ratio of the Unemployed and educated labor force (% of population) of Morocco in 1995 to that in 2003?
Your response must be concise. 0.84. What is the ratio of the Unemployed and educated labor force (% of population) of Romania in 1995 to that in 2003?
Ensure brevity in your answer.  1. What is the ratio of the Unemployed and educated labor force (% of population) in Belarus in 1995 to that in 2004?
Ensure brevity in your answer.  0.49. What is the ratio of the Unemployed and educated labor force (% of population) of Malta in 1995 to that in 2004?
Your answer should be very brief. 0.87. What is the ratio of the Unemployed and educated labor force (% of population) in Morocco in 1995 to that in 2004?
Ensure brevity in your answer.  0.83. What is the ratio of the Unemployed and educated labor force (% of population) in Romania in 1995 to that in 2004?
Give a very brief answer. 1.06. What is the ratio of the Unemployed and educated labor force (% of population) of Belarus in 1998 to that in 1999?
Your answer should be compact. 1.08. What is the ratio of the Unemployed and educated labor force (% of population) of Malta in 1998 to that in 1999?
Ensure brevity in your answer.  0.72. What is the ratio of the Unemployed and educated labor force (% of population) in Morocco in 1998 to that in 1999?
Give a very brief answer. 1.03. What is the ratio of the Unemployed and educated labor force (% of population) of Romania in 1998 to that in 1999?
Make the answer very short. 1.01. What is the ratio of the Unemployed and educated labor force (% of population) in Belarus in 1998 to that in 2000?
Give a very brief answer. 1.15. What is the ratio of the Unemployed and educated labor force (% of population) in Malta in 1998 to that in 2000?
Your answer should be very brief. 0.68. What is the ratio of the Unemployed and educated labor force (% of population) of Morocco in 1998 to that in 2000?
Offer a very short reply. 0.98. What is the ratio of the Unemployed and educated labor force (% of population) in Romania in 1998 to that in 2000?
Offer a terse response. 1.01. What is the ratio of the Unemployed and educated labor force (% of population) in Belarus in 1998 to that in 2001?
Your answer should be very brief. 1.1. What is the ratio of the Unemployed and educated labor force (% of population) of Malta in 1998 to that in 2001?
Provide a short and direct response. 0.49. What is the ratio of the Unemployed and educated labor force (% of population) in Morocco in 1998 to that in 2001?
Keep it short and to the point. 0.95. What is the ratio of the Unemployed and educated labor force (% of population) in Romania in 1998 to that in 2001?
Provide a succinct answer. 1.04. What is the ratio of the Unemployed and educated labor force (% of population) of Belarus in 1998 to that in 2002?
Your answer should be very brief. 0.97. What is the ratio of the Unemployed and educated labor force (% of population) in Malta in 1998 to that in 2002?
Offer a terse response. 0.72. What is the ratio of the Unemployed and educated labor force (% of population) in Morocco in 1998 to that in 2002?
Give a very brief answer. 0.98. What is the ratio of the Unemployed and educated labor force (% of population) in Romania in 1998 to that in 2002?
Your answer should be compact. 1.05. What is the ratio of the Unemployed and educated labor force (% of population) in Belarus in 1998 to that in 2003?
Provide a short and direct response. 0.93. What is the ratio of the Unemployed and educated labor force (% of population) of Malta in 1998 to that in 2003?
Make the answer very short. 0.55. What is the ratio of the Unemployed and educated labor force (% of population) in Morocco in 1998 to that in 2003?
Your answer should be very brief. 0.98. What is the ratio of the Unemployed and educated labor force (% of population) of Romania in 1998 to that in 2003?
Provide a succinct answer. 1.1. What is the ratio of the Unemployed and educated labor force (% of population) of Belarus in 1998 to that in 2004?
Your answer should be very brief. 0.41. What is the ratio of the Unemployed and educated labor force (% of population) in Malta in 1998 to that in 2004?
Provide a short and direct response. 0.63. What is the ratio of the Unemployed and educated labor force (% of population) in Morocco in 1998 to that in 2004?
Offer a very short reply. 0.97. What is the ratio of the Unemployed and educated labor force (% of population) in Romania in 1998 to that in 2004?
Provide a succinct answer. 1.17. What is the ratio of the Unemployed and educated labor force (% of population) in Belarus in 1999 to that in 2000?
Make the answer very short. 1.06. What is the ratio of the Unemployed and educated labor force (% of population) in Malta in 1999 to that in 2000?
Give a very brief answer. 0.93. What is the ratio of the Unemployed and educated labor force (% of population) in Morocco in 1999 to that in 2000?
Your response must be concise. 0.96. What is the ratio of the Unemployed and educated labor force (% of population) in Romania in 1999 to that in 2000?
Provide a succinct answer. 1. What is the ratio of the Unemployed and educated labor force (% of population) in Belarus in 1999 to that in 2001?
Provide a short and direct response. 1.01. What is the ratio of the Unemployed and educated labor force (% of population) in Malta in 1999 to that in 2001?
Offer a terse response. 0.68. What is the ratio of the Unemployed and educated labor force (% of population) of Morocco in 1999 to that in 2001?
Your answer should be very brief. 0.92. What is the ratio of the Unemployed and educated labor force (% of population) in Romania in 1999 to that in 2001?
Offer a terse response. 1.03. What is the ratio of the Unemployed and educated labor force (% of population) in Belarus in 1999 to that in 2002?
Give a very brief answer. 0.89. What is the ratio of the Unemployed and educated labor force (% of population) of Malta in 1999 to that in 2002?
Provide a succinct answer. 1. What is the ratio of the Unemployed and educated labor force (% of population) in Morocco in 1999 to that in 2002?
Provide a succinct answer. 0.96. What is the ratio of the Unemployed and educated labor force (% of population) in Romania in 1999 to that in 2002?
Give a very brief answer. 1.04. What is the ratio of the Unemployed and educated labor force (% of population) in Belarus in 1999 to that in 2003?
Your response must be concise. 0.86. What is the ratio of the Unemployed and educated labor force (% of population) of Malta in 1999 to that in 2003?
Make the answer very short. 0.77. What is the ratio of the Unemployed and educated labor force (% of population) of Morocco in 1999 to that in 2003?
Your answer should be very brief. 0.96. What is the ratio of the Unemployed and educated labor force (% of population) of Romania in 1999 to that in 2003?
Ensure brevity in your answer.  1.09. What is the ratio of the Unemployed and educated labor force (% of population) in Belarus in 1999 to that in 2004?
Provide a short and direct response. 0.38. What is the ratio of the Unemployed and educated labor force (% of population) in Malta in 1999 to that in 2004?
Your answer should be compact. 0.87. What is the ratio of the Unemployed and educated labor force (% of population) of Morocco in 1999 to that in 2004?
Give a very brief answer. 0.94. What is the ratio of the Unemployed and educated labor force (% of population) in Romania in 1999 to that in 2004?
Ensure brevity in your answer.  1.15. What is the ratio of the Unemployed and educated labor force (% of population) of Belarus in 2000 to that in 2001?
Your answer should be compact. 0.95. What is the ratio of the Unemployed and educated labor force (% of population) of Malta in 2000 to that in 2001?
Your answer should be very brief. 0.73. What is the ratio of the Unemployed and educated labor force (% of population) of Morocco in 2000 to that in 2001?
Provide a short and direct response. 0.97. What is the ratio of the Unemployed and educated labor force (% of population) in Romania in 2000 to that in 2001?
Provide a short and direct response. 1.03. What is the ratio of the Unemployed and educated labor force (% of population) of Belarus in 2000 to that in 2002?
Your answer should be very brief. 0.84. What is the ratio of the Unemployed and educated labor force (% of population) in Malta in 2000 to that in 2002?
Keep it short and to the point. 1.07. What is the ratio of the Unemployed and educated labor force (% of population) in Romania in 2000 to that in 2002?
Your answer should be compact. 1.04. What is the ratio of the Unemployed and educated labor force (% of population) of Belarus in 2000 to that in 2003?
Provide a succinct answer. 0.81. What is the ratio of the Unemployed and educated labor force (% of population) in Malta in 2000 to that in 2003?
Give a very brief answer. 0.82. What is the ratio of the Unemployed and educated labor force (% of population) of Romania in 2000 to that in 2003?
Your response must be concise. 1.09. What is the ratio of the Unemployed and educated labor force (% of population) of Belarus in 2000 to that in 2004?
Offer a very short reply. 0.36. What is the ratio of the Unemployed and educated labor force (% of population) of Malta in 2000 to that in 2004?
Offer a very short reply. 0.93. What is the ratio of the Unemployed and educated labor force (% of population) of Morocco in 2000 to that in 2004?
Your answer should be compact. 0.99. What is the ratio of the Unemployed and educated labor force (% of population) of Romania in 2000 to that in 2004?
Give a very brief answer. 1.15. What is the ratio of the Unemployed and educated labor force (% of population) in Belarus in 2001 to that in 2002?
Your answer should be compact. 0.88. What is the ratio of the Unemployed and educated labor force (% of population) of Malta in 2001 to that in 2002?
Offer a terse response. 1.46. What is the ratio of the Unemployed and educated labor force (% of population) of Morocco in 2001 to that in 2002?
Your answer should be very brief. 1.04. What is the ratio of the Unemployed and educated labor force (% of population) in Romania in 2001 to that in 2002?
Ensure brevity in your answer.  1.01. What is the ratio of the Unemployed and educated labor force (% of population) in Belarus in 2001 to that in 2003?
Your response must be concise. 0.85. What is the ratio of the Unemployed and educated labor force (% of population) in Malta in 2001 to that in 2003?
Make the answer very short. 1.12. What is the ratio of the Unemployed and educated labor force (% of population) in Morocco in 2001 to that in 2003?
Your answer should be very brief. 1.04. What is the ratio of the Unemployed and educated labor force (% of population) of Romania in 2001 to that in 2003?
Offer a very short reply. 1.06. What is the ratio of the Unemployed and educated labor force (% of population) in Belarus in 2001 to that in 2004?
Offer a terse response. 0.38. What is the ratio of the Unemployed and educated labor force (% of population) in Malta in 2001 to that in 2004?
Offer a terse response. 1.27. What is the ratio of the Unemployed and educated labor force (% of population) in Morocco in 2001 to that in 2004?
Make the answer very short. 1.02. What is the ratio of the Unemployed and educated labor force (% of population) in Romania in 2001 to that in 2004?
Give a very brief answer. 1.12. What is the ratio of the Unemployed and educated labor force (% of population) of Belarus in 2002 to that in 2003?
Provide a succinct answer. 0.96. What is the ratio of the Unemployed and educated labor force (% of population) of Malta in 2002 to that in 2003?
Your answer should be very brief. 0.77. What is the ratio of the Unemployed and educated labor force (% of population) of Morocco in 2002 to that in 2003?
Your answer should be very brief. 1. What is the ratio of the Unemployed and educated labor force (% of population) in Romania in 2002 to that in 2003?
Provide a short and direct response. 1.04. What is the ratio of the Unemployed and educated labor force (% of population) in Belarus in 2002 to that in 2004?
Keep it short and to the point. 0.43. What is the ratio of the Unemployed and educated labor force (% of population) of Malta in 2002 to that in 2004?
Offer a terse response. 0.87. What is the ratio of the Unemployed and educated labor force (% of population) of Morocco in 2002 to that in 2004?
Keep it short and to the point. 0.99. What is the ratio of the Unemployed and educated labor force (% of population) in Romania in 2002 to that in 2004?
Offer a very short reply. 1.11. What is the ratio of the Unemployed and educated labor force (% of population) of Belarus in 2003 to that in 2004?
Provide a short and direct response. 0.45. What is the ratio of the Unemployed and educated labor force (% of population) in Malta in 2003 to that in 2004?
Provide a succinct answer. 1.14. What is the ratio of the Unemployed and educated labor force (% of population) in Morocco in 2003 to that in 2004?
Make the answer very short. 0.99. What is the ratio of the Unemployed and educated labor force (% of population) of Romania in 2003 to that in 2004?
Ensure brevity in your answer.  1.06. What is the difference between the highest and the second highest Unemployed and educated labor force (% of population) of Belarus?
Give a very brief answer. 20.8. What is the difference between the highest and the second highest Unemployed and educated labor force (% of population) in Malta?
Keep it short and to the point. 2. What is the difference between the highest and the second highest Unemployed and educated labor force (% of population) in Romania?
Provide a short and direct response. 0.9. What is the difference between the highest and the lowest Unemployed and educated labor force (% of population) in Belarus?
Give a very brief answer. 26. What is the difference between the highest and the lowest Unemployed and educated labor force (% of population) of Morocco?
Offer a terse response. 4.3. What is the difference between the highest and the lowest Unemployed and educated labor force (% of population) in Romania?
Your answer should be compact. 10.9. 